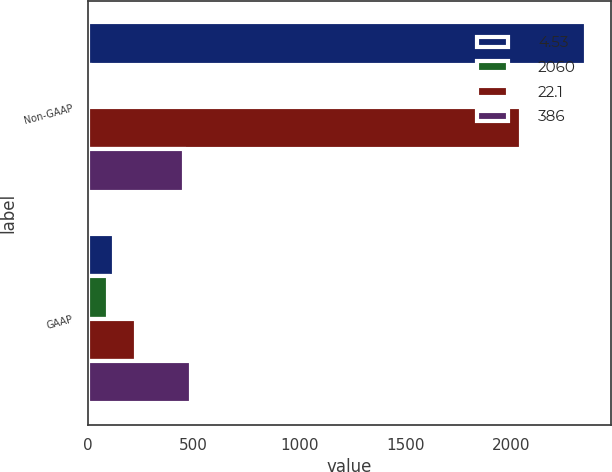Convert chart to OTSL. <chart><loc_0><loc_0><loc_500><loc_500><stacked_bar_chart><ecel><fcel>Non-GAAP<fcel>GAAP<nl><fcel>4.53<fcel>2353<fcel>126<nl><fcel>2060<fcel>9<fcel>94<nl><fcel>22.1<fcel>2044<fcel>228<nl><fcel>386<fcel>453<fcel>487<nl></chart> 